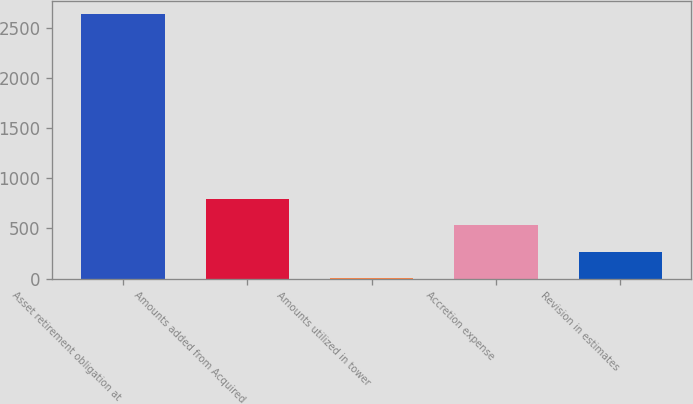<chart> <loc_0><loc_0><loc_500><loc_500><bar_chart><fcel>Asset retirement obligation at<fcel>Amounts added from Acquired<fcel>Amounts utilized in tower<fcel>Accretion expense<fcel>Revision in estimates<nl><fcel>2632<fcel>792.4<fcel>4<fcel>529.6<fcel>266.8<nl></chart> 